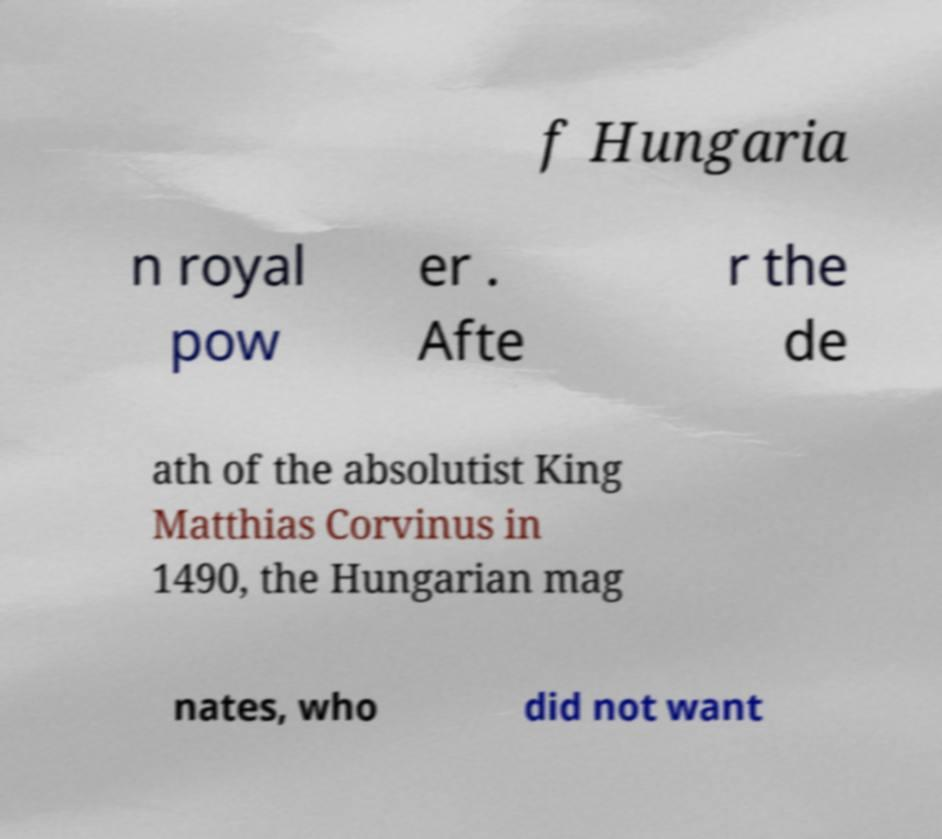Could you extract and type out the text from this image? f Hungaria n royal pow er . Afte r the de ath of the absolutist King Matthias Corvinus in 1490, the Hungarian mag nates, who did not want 